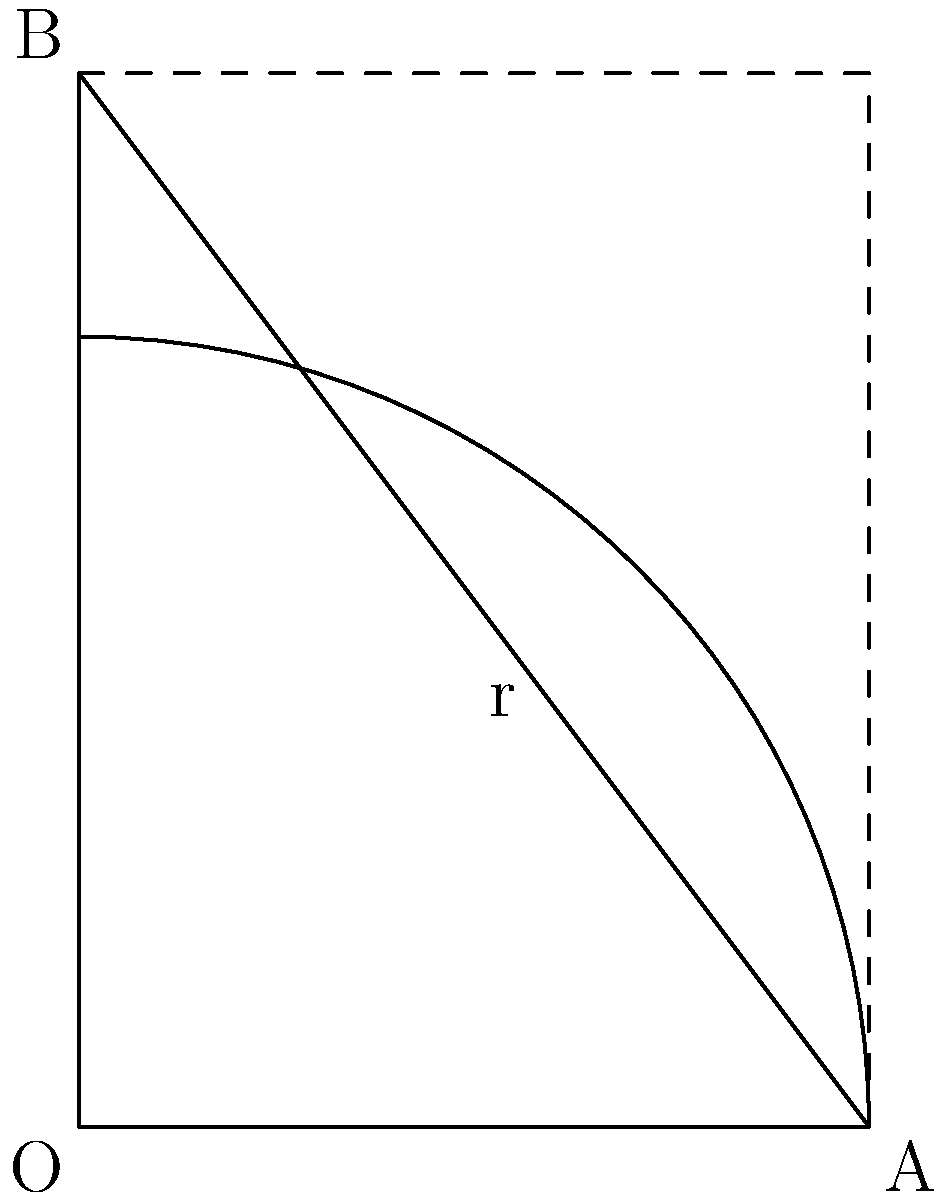You want to place a circular area rug in the corner of your dorm room. The rug should touch both walls and fit perfectly in the right angle formed by the walls. If one wall is 6 feet long and the other is 8 feet long, what should be the radius of the rug to the nearest tenth of a foot? Let's approach this step-by-step:

1) We can treat this as a right triangle problem where the radius of the rug forms the hypotenuse of two right triangles.

2) Let the radius of the rug be $r$. The two legs of our large right triangle are 6 and 8 feet.

3) We can use the Pythagorean theorem to set up our equation:

   $r^2 + r^2 = 6^2 + 8^2$

4) Simplify the left side:

   $2r^2 = 6^2 + 8^2$

5) Calculate the right side:

   $2r^2 = 36 + 64 = 100$

6) Divide both sides by 2:

   $r^2 = 50$

7) Take the square root of both sides:

   $r = \sqrt{50}$

8) Simplify:

   $r = 5\sqrt{2} \approx 7.071$

9) Rounding to the nearest tenth:

   $r \approx 7.1$ feet
Answer: 7.1 feet 